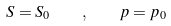Convert formula to latex. <formula><loc_0><loc_0><loc_500><loc_500>S = S _ { 0 } \quad , \quad p = p _ { 0 }</formula> 